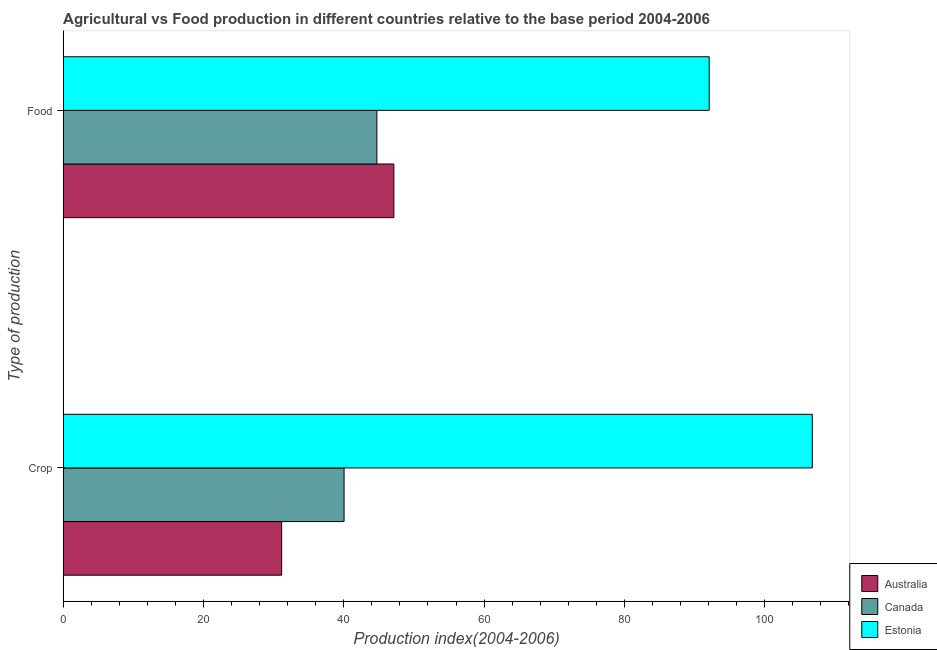How many groups of bars are there?
Your answer should be compact. 2. How many bars are there on the 2nd tick from the top?
Ensure brevity in your answer.  3. How many bars are there on the 1st tick from the bottom?
Offer a terse response. 3. What is the label of the 2nd group of bars from the top?
Keep it short and to the point. Crop. What is the food production index in Canada?
Offer a terse response. 44.72. Across all countries, what is the maximum food production index?
Your answer should be very brief. 92.1. Across all countries, what is the minimum food production index?
Offer a very short reply. 44.72. In which country was the crop production index maximum?
Offer a terse response. Estonia. In which country was the food production index minimum?
Offer a terse response. Canada. What is the total food production index in the graph?
Offer a terse response. 183.96. What is the difference between the crop production index in Canada and that in Estonia?
Ensure brevity in your answer.  -66.76. What is the difference between the crop production index in Estonia and the food production index in Australia?
Give a very brief answer. 59.66. What is the average food production index per country?
Give a very brief answer. 61.32. What is the difference between the food production index and crop production index in Estonia?
Provide a short and direct response. -14.7. What is the ratio of the crop production index in Canada to that in Estonia?
Give a very brief answer. 0.37. In how many countries, is the food production index greater than the average food production index taken over all countries?
Provide a succinct answer. 1. What does the 3rd bar from the bottom in Food represents?
Ensure brevity in your answer.  Estonia. How many bars are there?
Offer a very short reply. 6. How many countries are there in the graph?
Provide a short and direct response. 3. Are the values on the major ticks of X-axis written in scientific E-notation?
Offer a very short reply. No. Does the graph contain grids?
Your answer should be very brief. No. Where does the legend appear in the graph?
Ensure brevity in your answer.  Bottom right. What is the title of the graph?
Your answer should be very brief. Agricultural vs Food production in different countries relative to the base period 2004-2006. Does "Congo (Republic)" appear as one of the legend labels in the graph?
Give a very brief answer. No. What is the label or title of the X-axis?
Your response must be concise. Production index(2004-2006). What is the label or title of the Y-axis?
Give a very brief answer. Type of production. What is the Production index(2004-2006) of Australia in Crop?
Provide a short and direct response. 31.14. What is the Production index(2004-2006) of Canada in Crop?
Your answer should be compact. 40.04. What is the Production index(2004-2006) of Estonia in Crop?
Give a very brief answer. 106.8. What is the Production index(2004-2006) in Australia in Food?
Provide a succinct answer. 47.14. What is the Production index(2004-2006) in Canada in Food?
Ensure brevity in your answer.  44.72. What is the Production index(2004-2006) of Estonia in Food?
Offer a very short reply. 92.1. Across all Type of production, what is the maximum Production index(2004-2006) in Australia?
Make the answer very short. 47.14. Across all Type of production, what is the maximum Production index(2004-2006) in Canada?
Your answer should be very brief. 44.72. Across all Type of production, what is the maximum Production index(2004-2006) of Estonia?
Your answer should be compact. 106.8. Across all Type of production, what is the minimum Production index(2004-2006) of Australia?
Ensure brevity in your answer.  31.14. Across all Type of production, what is the minimum Production index(2004-2006) of Canada?
Your response must be concise. 40.04. Across all Type of production, what is the minimum Production index(2004-2006) of Estonia?
Keep it short and to the point. 92.1. What is the total Production index(2004-2006) of Australia in the graph?
Your answer should be very brief. 78.28. What is the total Production index(2004-2006) in Canada in the graph?
Offer a terse response. 84.76. What is the total Production index(2004-2006) of Estonia in the graph?
Offer a very short reply. 198.9. What is the difference between the Production index(2004-2006) in Australia in Crop and that in Food?
Make the answer very short. -16. What is the difference between the Production index(2004-2006) of Canada in Crop and that in Food?
Give a very brief answer. -4.68. What is the difference between the Production index(2004-2006) of Australia in Crop and the Production index(2004-2006) of Canada in Food?
Offer a very short reply. -13.58. What is the difference between the Production index(2004-2006) of Australia in Crop and the Production index(2004-2006) of Estonia in Food?
Provide a short and direct response. -60.96. What is the difference between the Production index(2004-2006) of Canada in Crop and the Production index(2004-2006) of Estonia in Food?
Offer a very short reply. -52.06. What is the average Production index(2004-2006) in Australia per Type of production?
Your answer should be compact. 39.14. What is the average Production index(2004-2006) of Canada per Type of production?
Offer a very short reply. 42.38. What is the average Production index(2004-2006) of Estonia per Type of production?
Offer a terse response. 99.45. What is the difference between the Production index(2004-2006) in Australia and Production index(2004-2006) in Estonia in Crop?
Your answer should be compact. -75.66. What is the difference between the Production index(2004-2006) in Canada and Production index(2004-2006) in Estonia in Crop?
Offer a very short reply. -66.76. What is the difference between the Production index(2004-2006) of Australia and Production index(2004-2006) of Canada in Food?
Your response must be concise. 2.42. What is the difference between the Production index(2004-2006) in Australia and Production index(2004-2006) in Estonia in Food?
Your response must be concise. -44.96. What is the difference between the Production index(2004-2006) of Canada and Production index(2004-2006) of Estonia in Food?
Offer a terse response. -47.38. What is the ratio of the Production index(2004-2006) of Australia in Crop to that in Food?
Your answer should be very brief. 0.66. What is the ratio of the Production index(2004-2006) in Canada in Crop to that in Food?
Offer a very short reply. 0.9. What is the ratio of the Production index(2004-2006) in Estonia in Crop to that in Food?
Ensure brevity in your answer.  1.16. What is the difference between the highest and the second highest Production index(2004-2006) of Canada?
Your response must be concise. 4.68. What is the difference between the highest and the second highest Production index(2004-2006) of Estonia?
Offer a very short reply. 14.7. What is the difference between the highest and the lowest Production index(2004-2006) in Australia?
Make the answer very short. 16. What is the difference between the highest and the lowest Production index(2004-2006) of Canada?
Make the answer very short. 4.68. What is the difference between the highest and the lowest Production index(2004-2006) in Estonia?
Provide a succinct answer. 14.7. 